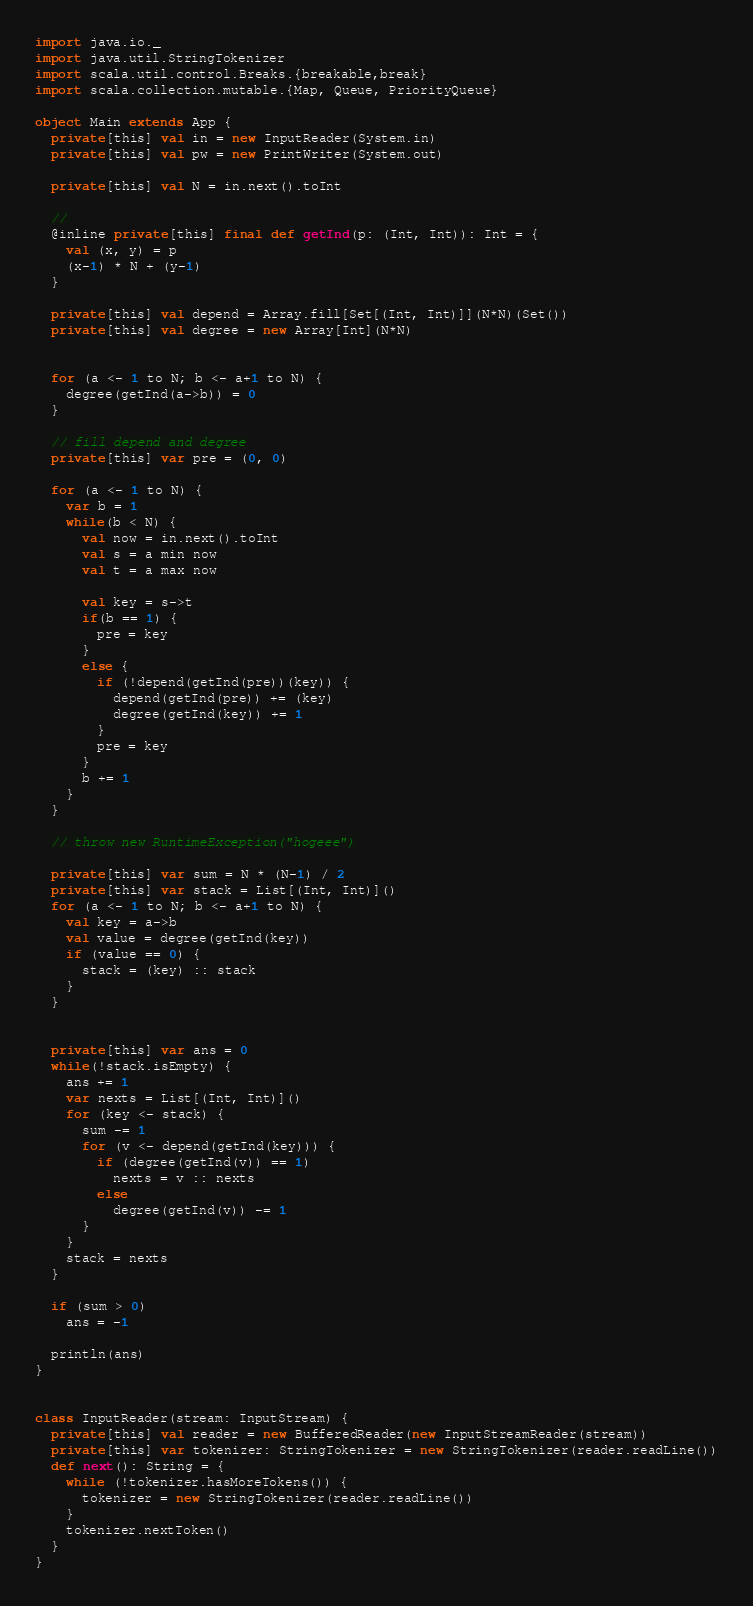Convert code to text. <code><loc_0><loc_0><loc_500><loc_500><_Scala_>import java.io._
import java.util.StringTokenizer
import scala.util.control.Breaks.{breakable,break}
import scala.collection.mutable.{Map, Queue, PriorityQueue}

object Main extends App {
  private[this] val in = new InputReader(System.in)
  private[this] val pw = new PrintWriter(System.out)

  private[this] val N = in.next().toInt

  //
  @inline private[this] final def getInd(p: (Int, Int)): Int = {
    val (x, y) = p
    (x-1) * N + (y-1)
  }

  private[this] val depend = Array.fill[Set[(Int, Int)]](N*N)(Set())
  private[this] val degree = new Array[Int](N*N)

  
  for (a <- 1 to N; b <- a+1 to N) {
    degree(getInd(a->b)) = 0
  }

  // fill depend and degree
  private[this] var pre = (0, 0)

  for (a <- 1 to N) {
    var b = 1
    while(b < N) {
      val now = in.next().toInt
      val s = a min now
      val t = a max now

      val key = s->t
      if(b == 1) {
        pre = key
      }
      else {
        if (!depend(getInd(pre))(key)) {
          depend(getInd(pre)) += (key)
          degree(getInd(key)) += 1
        }
        pre = key
      }
      b += 1
    }
  }

  // throw new RuntimeException("hogeee")

  private[this] var sum = N * (N-1) / 2
  private[this] var stack = List[(Int, Int)]()
  for (a <- 1 to N; b <- a+1 to N) {
    val key = a->b
    val value = degree(getInd(key))
    if (value == 0) {
      stack = (key) :: stack
    }
  }


  private[this] var ans = 0
  while(!stack.isEmpty) {
    ans += 1
    var nexts = List[(Int, Int)]()
    for (key <- stack) {
      sum -= 1
      for (v <- depend(getInd(key))) {
        if (degree(getInd(v)) == 1)
          nexts = v :: nexts
        else
          degree(getInd(v)) -= 1
      }
    }
    stack = nexts
  }

  if (sum > 0)
    ans = -1

  println(ans)
}


class InputReader(stream: InputStream) {
  private[this] val reader = new BufferedReader(new InputStreamReader(stream))
  private[this] var tokenizer: StringTokenizer = new StringTokenizer(reader.readLine())
  def next(): String = {
    while (!tokenizer.hasMoreTokens()) {
      tokenizer = new StringTokenizer(reader.readLine())
    }
    tokenizer.nextToken()
  }
}
</code> 